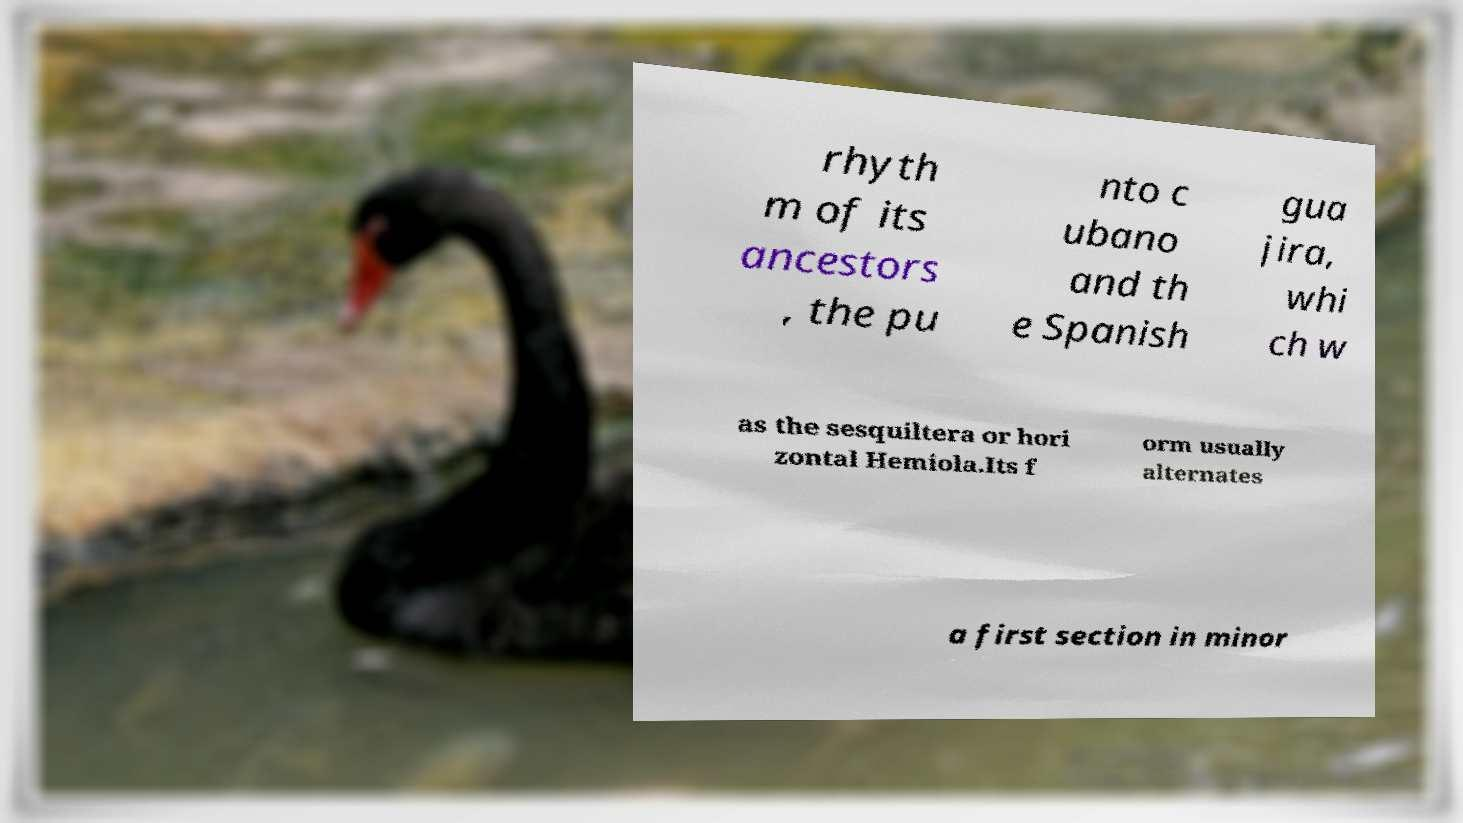Could you assist in decoding the text presented in this image and type it out clearly? rhyth m of its ancestors , the pu nto c ubano and th e Spanish gua jira, whi ch w as the sesquiltera or hori zontal Hemiola.Its f orm usually alternates a first section in minor 